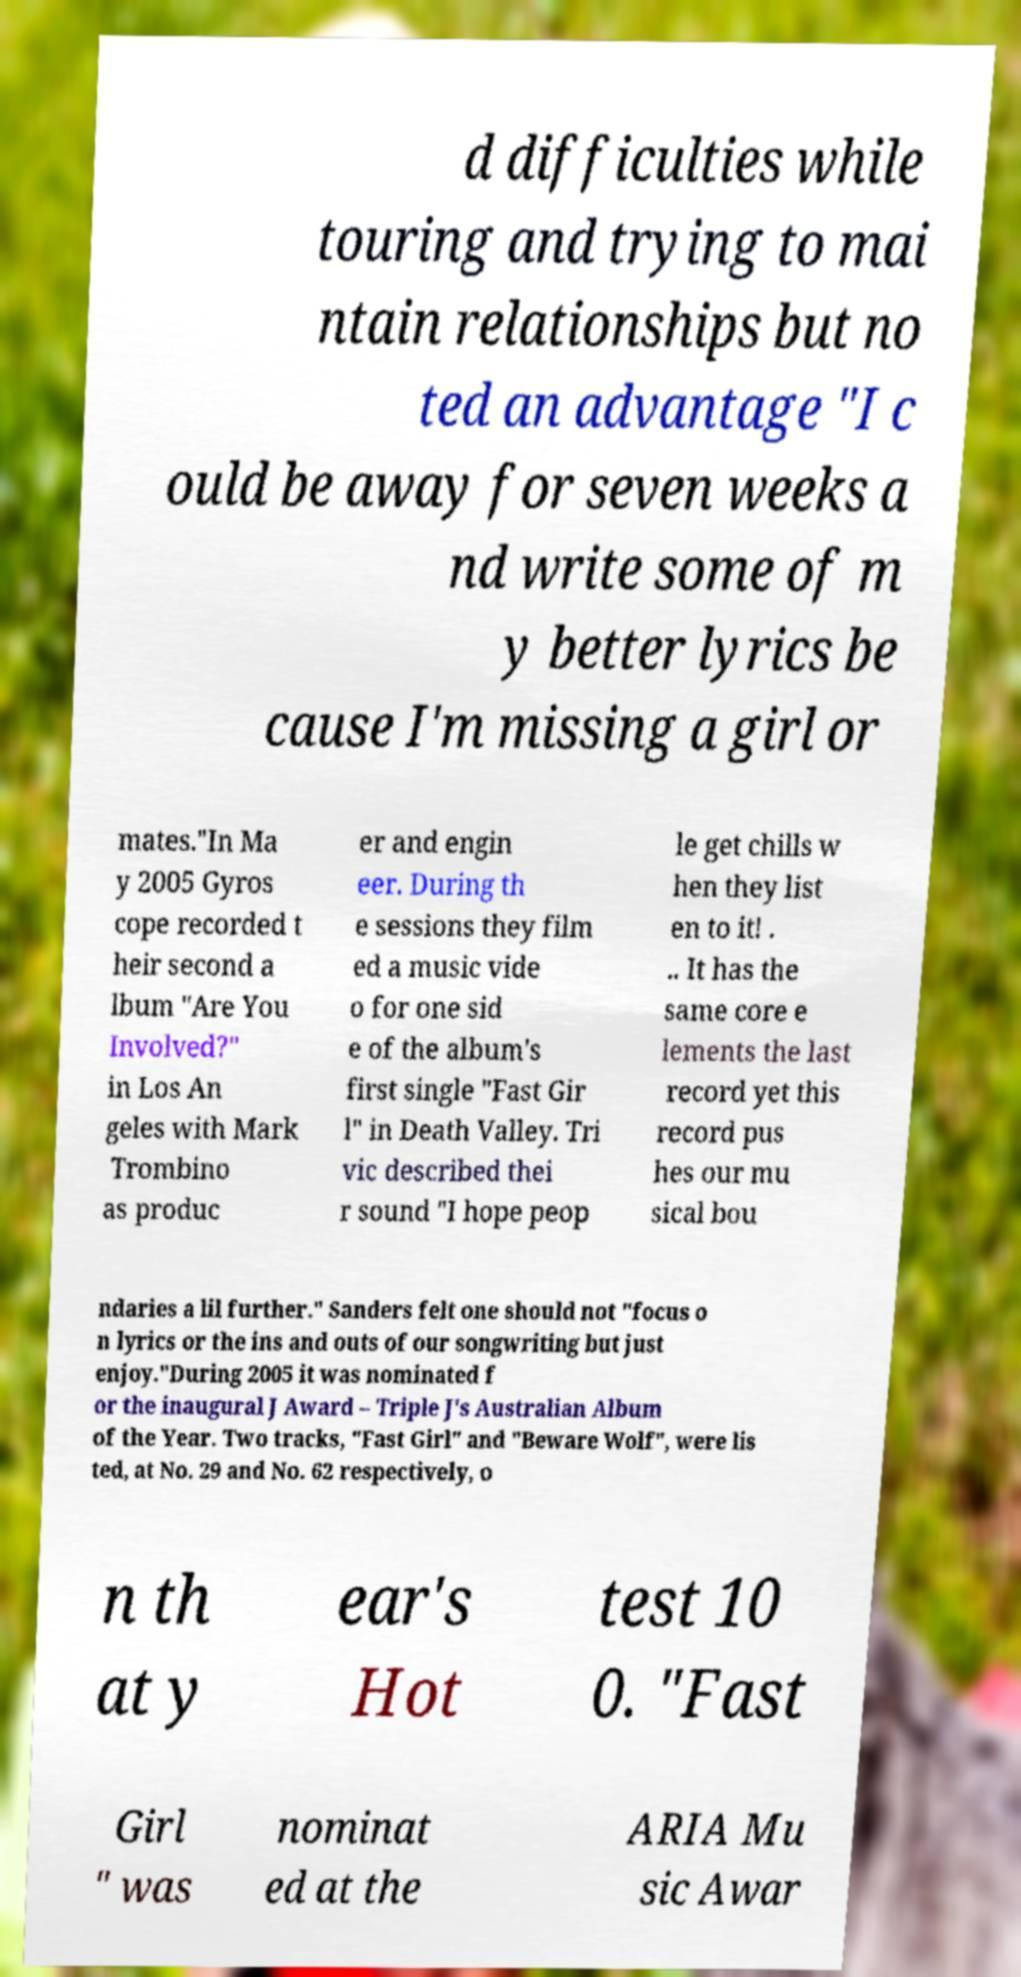Please read and relay the text visible in this image. What does it say? d difficulties while touring and trying to mai ntain relationships but no ted an advantage "I c ould be away for seven weeks a nd write some of m y better lyrics be cause I'm missing a girl or mates."In Ma y 2005 Gyros cope recorded t heir second a lbum "Are You Involved?" in Los An geles with Mark Trombino as produc er and engin eer. During th e sessions they film ed a music vide o for one sid e of the album's first single "Fast Gir l" in Death Valley. Tri vic described thei r sound "I hope peop le get chills w hen they list en to it! . .. It has the same core e lements the last record yet this record pus hes our mu sical bou ndaries a lil further." Sanders felt one should not "focus o n lyrics or the ins and outs of our songwriting but just enjoy."During 2005 it was nominated f or the inaugural J Award – Triple J's Australian Album of the Year. Two tracks, "Fast Girl" and "Beware Wolf", were lis ted, at No. 29 and No. 62 respectively, o n th at y ear's Hot test 10 0. "Fast Girl " was nominat ed at the ARIA Mu sic Awar 